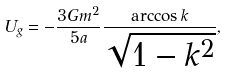Convert formula to latex. <formula><loc_0><loc_0><loc_500><loc_500>U _ { g } = - \frac { 3 G m ^ { 2 } } { 5 a } \frac { \arccos { k } } { \sqrt { 1 - k ^ { 2 } } } ,</formula> 